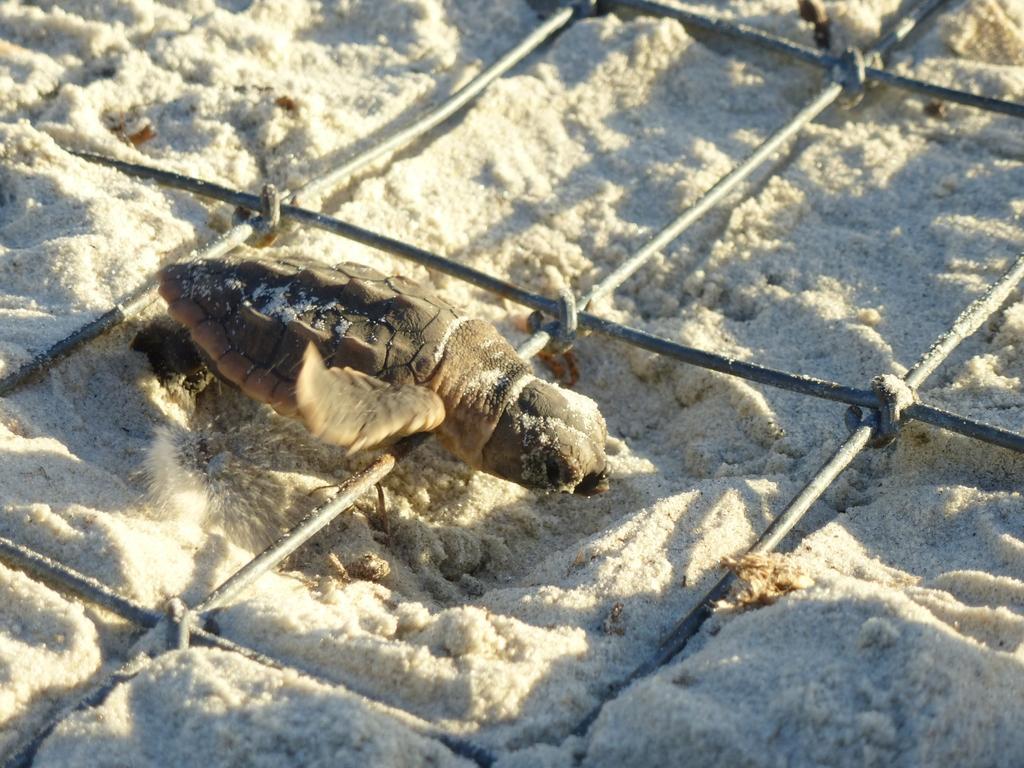Describe this image in one or two sentences. In the foreground of this image, it seems like a turtle on a mesh which is on the white sand. 